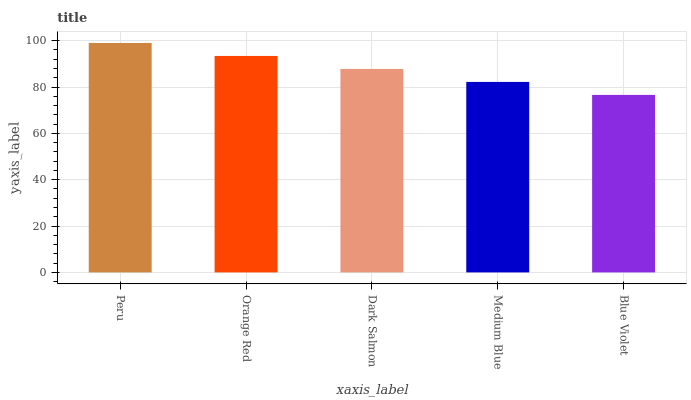Is Orange Red the minimum?
Answer yes or no. No. Is Orange Red the maximum?
Answer yes or no. No. Is Peru greater than Orange Red?
Answer yes or no. Yes. Is Orange Red less than Peru?
Answer yes or no. Yes. Is Orange Red greater than Peru?
Answer yes or no. No. Is Peru less than Orange Red?
Answer yes or no. No. Is Dark Salmon the high median?
Answer yes or no. Yes. Is Dark Salmon the low median?
Answer yes or no. Yes. Is Medium Blue the high median?
Answer yes or no. No. Is Peru the low median?
Answer yes or no. No. 